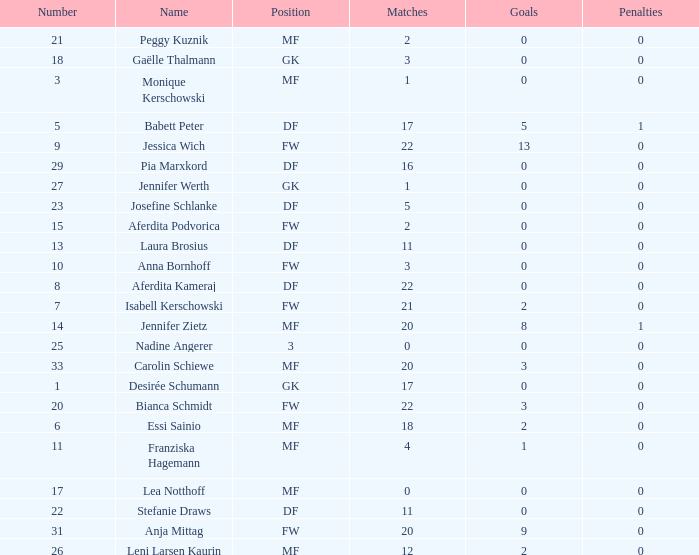What is the average goals for Essi Sainio? 2.0. 